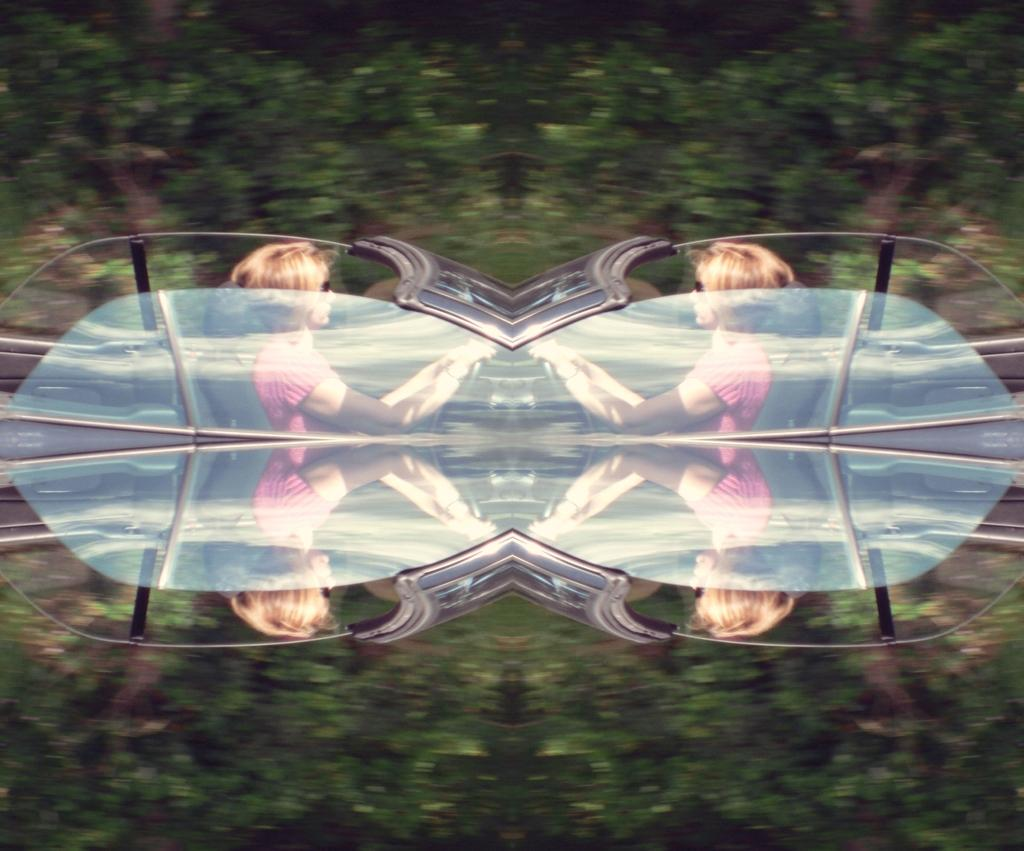What type of image is being shown? The image is an edited image. Who is present in the image? There is a woman in the image. What is the woman doing in the image? The woman appears to be driving a car. How would you describe the background of the image? The background of the image is blurry. How does the queen express her anger in the image? There is no queen present in the image, and therefore no expression of anger can be observed. 